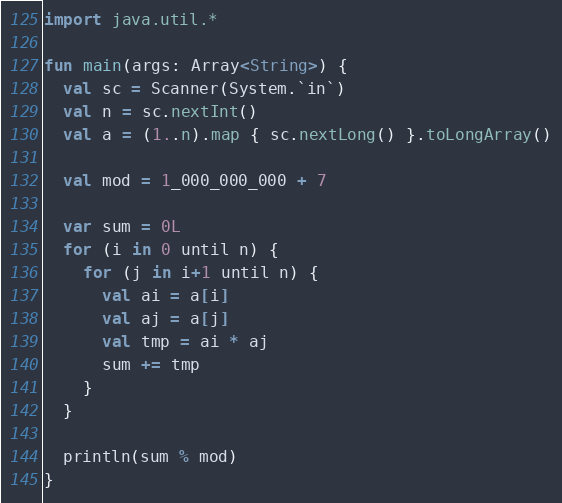Convert code to text. <code><loc_0><loc_0><loc_500><loc_500><_Kotlin_>import java.util.*

fun main(args: Array<String>) {
  val sc = Scanner(System.`in`)
  val n = sc.nextInt()
  val a = (1..n).map { sc.nextLong() }.toLongArray()
   
  val mod = 1_000_000_000 + 7

  var sum = 0L
  for (i in 0 until n) {
    for (j in i+1 until n) {
      val ai = a[i]
      val aj = a[j]
      val tmp = ai * aj
      sum += tmp
    }
  }

  println(sum % mod)
}
</code> 